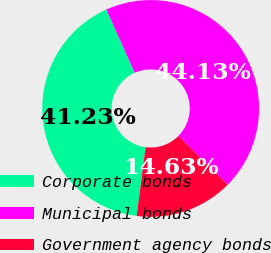<chart> <loc_0><loc_0><loc_500><loc_500><pie_chart><fcel>Corporate bonds<fcel>Municipal bonds<fcel>Government agency bonds<nl><fcel>41.23%<fcel>44.13%<fcel>14.63%<nl></chart> 